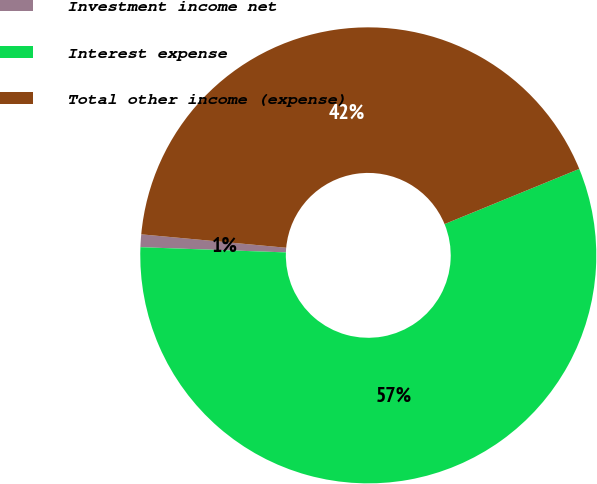<chart> <loc_0><loc_0><loc_500><loc_500><pie_chart><fcel>Investment income net<fcel>Interest expense<fcel>Total other income (expense)<nl><fcel>0.9%<fcel>56.76%<fcel>42.34%<nl></chart> 